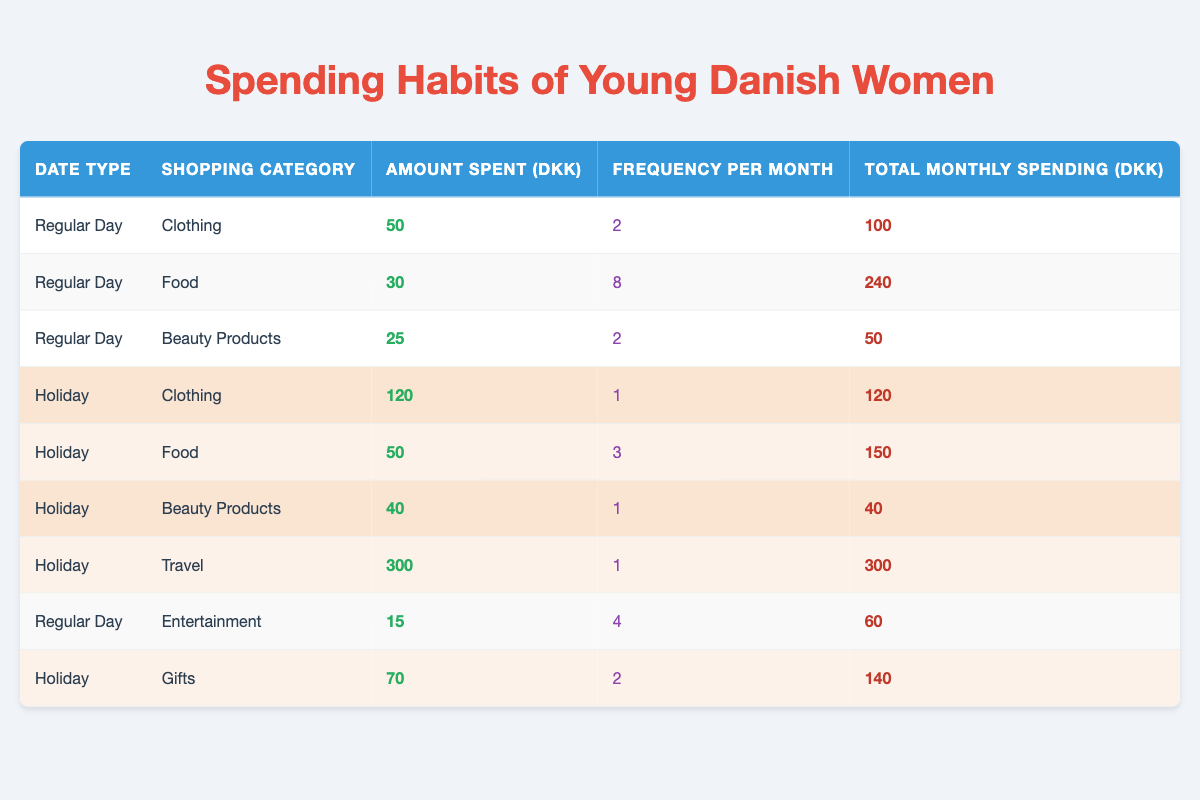What is the total amount spent on Food during Regular Days? To find the total amount spent on Food during Regular Days, we look at the row where Date Type is "Regular Day" and Shopping Category is "Food." The total monthly spending for that category is listed as 240 DKK.
Answer: 240 DKK What is the average amount spent on Beauty Products during Holidays? For Beauty Products during Holidays, there is one entry with an amount spent of 40 DKK. Since there is only one data point, the average is simply that value, which is 40 DKK.
Answer: 40 DKK Is the total monthly spending on Gifts during Holidays greater than that for Clothing during Regular Days? The total monthly spending for Gifts during Holidays is 140 DKK, and for Clothing during Regular Days, it is 100 DKK. Since 140 DKK is greater than 100 DKK, the answer is yes.
Answer: Yes How much more is spent on Travel during Holidays compared to Entertainment during Regular Days? For Travel during Holidays, the total monthly spending is 300 DKK. For Entertainment during Regular Days, the total monthly spending is 60 DKK. The difference is 300 - 60 = 240 DKK.
Answer: 240 DKK What is the total frequency of Shopping Categories on Regular Days? We add the frequency for all Shopping Categories on Regular Days: 2 (Clothing) + 8 (Food) + 2 (Beauty Products) + 4 (Entertainment) = 16.
Answer: 16 Are the total spending amounts on Holidays and Regular Days the same for any specific category? Upon examining each category, the amounts do not match across Holidays and Regular Days; all figures are unique. Therefore, no category has the same total spending on both types of days.
Answer: No Which category has the highest spending on Holidays, and what is the amount? By examining the entries under Holidays, Travel shows the highest spending at 300 DKK, making it the top category for Holiday spending.
Answer: Travel, 300 DKK What percentage of the total monthly spending on Food during Holidays comes from the spending on Gifts? The total spending on Food during Holidays is 150 DKK, and the spending on Gifts is 140 DKK. The calculation for percentage is (140 / 150) * 100 = 93.33%.
Answer: 93.33% 